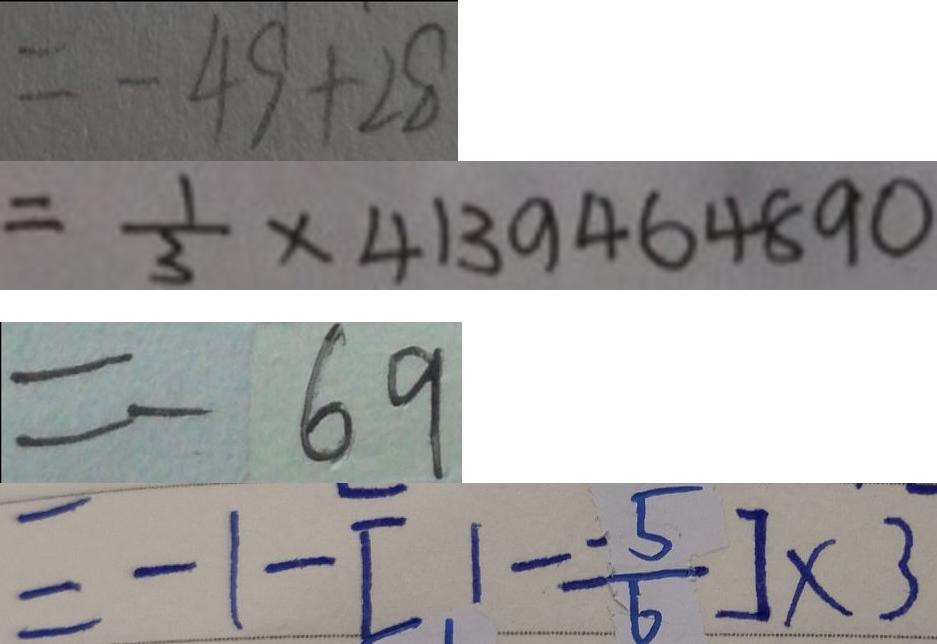<formula> <loc_0><loc_0><loc_500><loc_500>= - 4 9 + 2 8 
 = \frac { 1 } { 3 } \times 4 1 3 9 4 6 4 8 9 0 
 = - 6 9 
 = - 1 - [ 1 - \frac { - 5 } { 6 } ] \times 3</formula> 